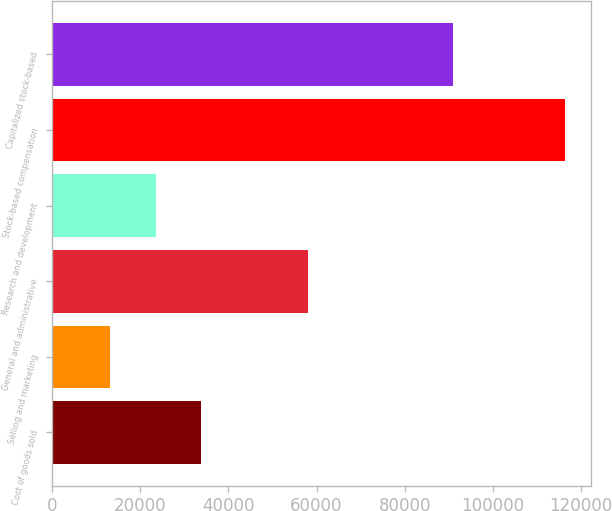Convert chart. <chart><loc_0><loc_0><loc_500><loc_500><bar_chart><fcel>Cost of goods sold<fcel>Selling and marketing<fcel>General and administrative<fcel>Research and development<fcel>Stock-based compensation<fcel>Capitalized stock-based<nl><fcel>33876.2<fcel>13258<fcel>58037<fcel>23567.1<fcel>116349<fcel>90914<nl></chart> 